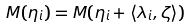Convert formula to latex. <formula><loc_0><loc_0><loc_500><loc_500>M ( \eta _ { i } ) = M ( \eta _ { i } + \langle \lambda _ { i } , \zeta \rangle )</formula> 